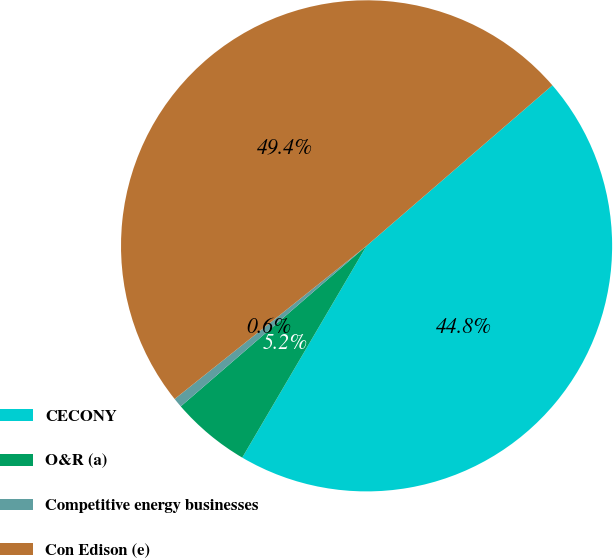<chart> <loc_0><loc_0><loc_500><loc_500><pie_chart><fcel>CECONY<fcel>O&R (a)<fcel>Competitive energy businesses<fcel>Con Edison (e)<nl><fcel>44.79%<fcel>5.21%<fcel>0.62%<fcel>49.38%<nl></chart> 